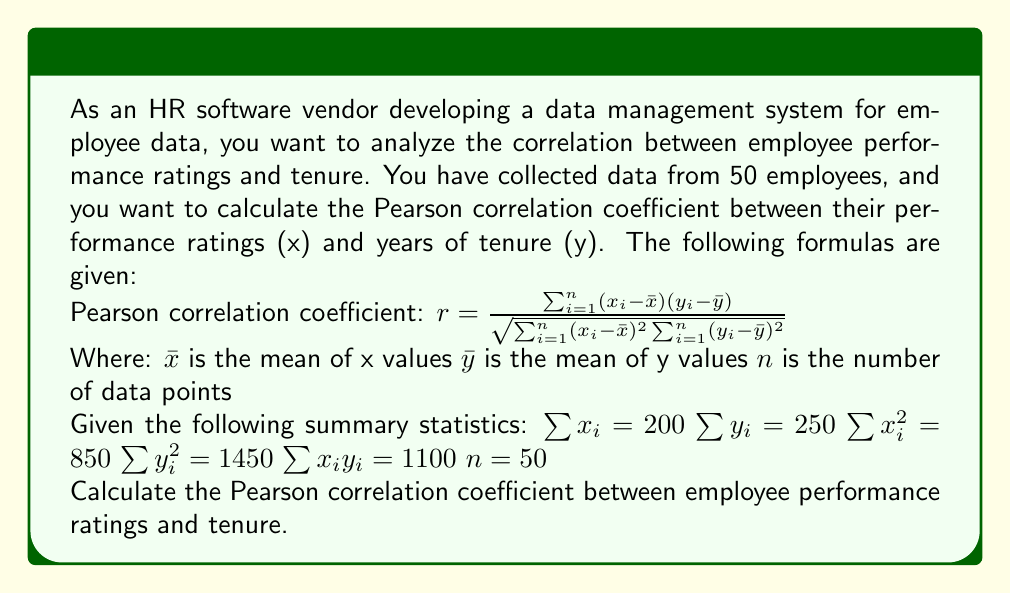Can you answer this question? To calculate the Pearson correlation coefficient, we'll follow these steps:

1. Calculate the means $\bar{x}$ and $\bar{y}$:
   $\bar{x} = \frac{\sum x_i}{n} = \frac{200}{50} = 4$
   $\bar{y} = \frac{\sum y_i}{n} = \frac{250}{50} = 5$

2. Calculate $\sum_{i=1}^{n} x_iy_i - n\bar{x}\bar{y}$:
   $\sum_{i=1}^{n} x_iy_i - n\bar{x}\bar{y} = 1100 - 50(4)(5) = 1100 - 1000 = 100$

3. Calculate $\sum_{i=1}^{n} x_i^2 - n\bar{x}^2$:
   $\sum_{i=1}^{n} x_i^2 - n\bar{x}^2 = 850 - 50(4^2) = 850 - 800 = 50$

4. Calculate $\sum_{i=1}^{n} y_i^2 - n\bar{y}^2$:
   $\sum_{i=1}^{n} y_i^2 - n\bar{y}^2 = 1450 - 50(5^2) = 1450 - 1250 = 200$

5. Apply the Pearson correlation coefficient formula:

   $$r = \frac{\sum_{i=1}^{n} x_iy_i - n\bar{x}\bar{y}}{\sqrt{(\sum_{i=1}^{n} x_i^2 - n\bar{x}^2)(\sum_{i=1}^{n} y_i^2 - n\bar{y}^2)}}$$

   $$r = \frac{100}{\sqrt{(50)(200)}}$$

   $$r = \frac{100}{\sqrt{10000}}$$

   $$r = \frac{100}{100}$$

   $$r = 1$$
Answer: The Pearson correlation coefficient between employee performance ratings and tenure is 1, indicating a perfect positive linear correlation. 